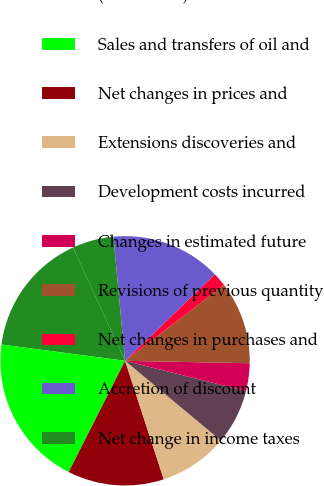Convert chart. <chart><loc_0><loc_0><loc_500><loc_500><pie_chart><fcel>(In millions)<fcel>Sales and transfers of oil and<fcel>Net changes in prices and<fcel>Extensions discoveries and<fcel>Development costs incurred<fcel>Changes in estimated future<fcel>Revisions of previous quantity<fcel>Net changes in purchases and<fcel>Accretion of discount<fcel>Net change in income taxes<nl><fcel>16.06%<fcel>19.62%<fcel>12.49%<fcel>8.93%<fcel>7.15%<fcel>3.59%<fcel>10.71%<fcel>1.81%<fcel>14.28%<fcel>5.37%<nl></chart> 